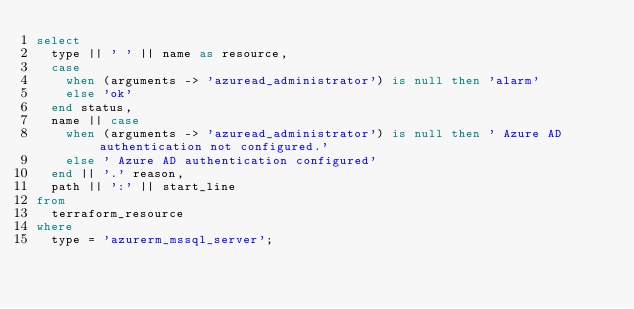<code> <loc_0><loc_0><loc_500><loc_500><_SQL_>select
  type || ' ' || name as resource,
  case
    when (arguments -> 'azuread_administrator') is null then 'alarm'
    else 'ok'
  end status,
  name || case
    when (arguments -> 'azuread_administrator') is null then ' Azure AD authentication not configured.'
    else ' Azure AD authentication configured'
  end || '.' reason,
  path || ':' || start_line
from
  terraform_resource
where
  type = 'azurerm_mssql_server';
</code> 